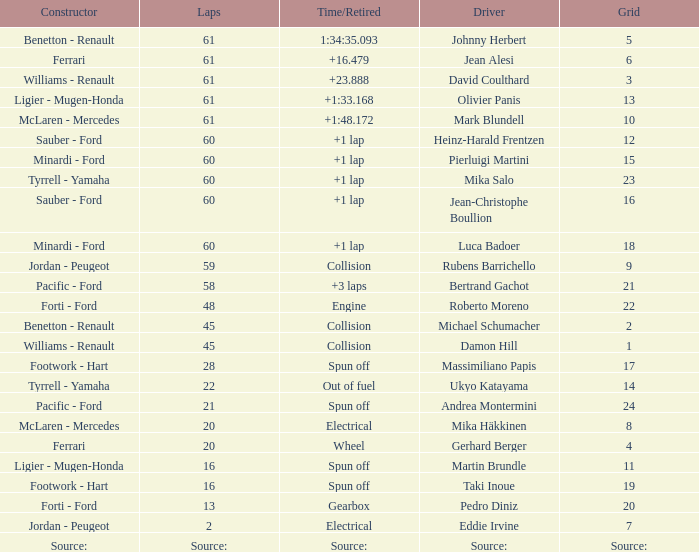What's the time/retired for constructor source:? Source:. 